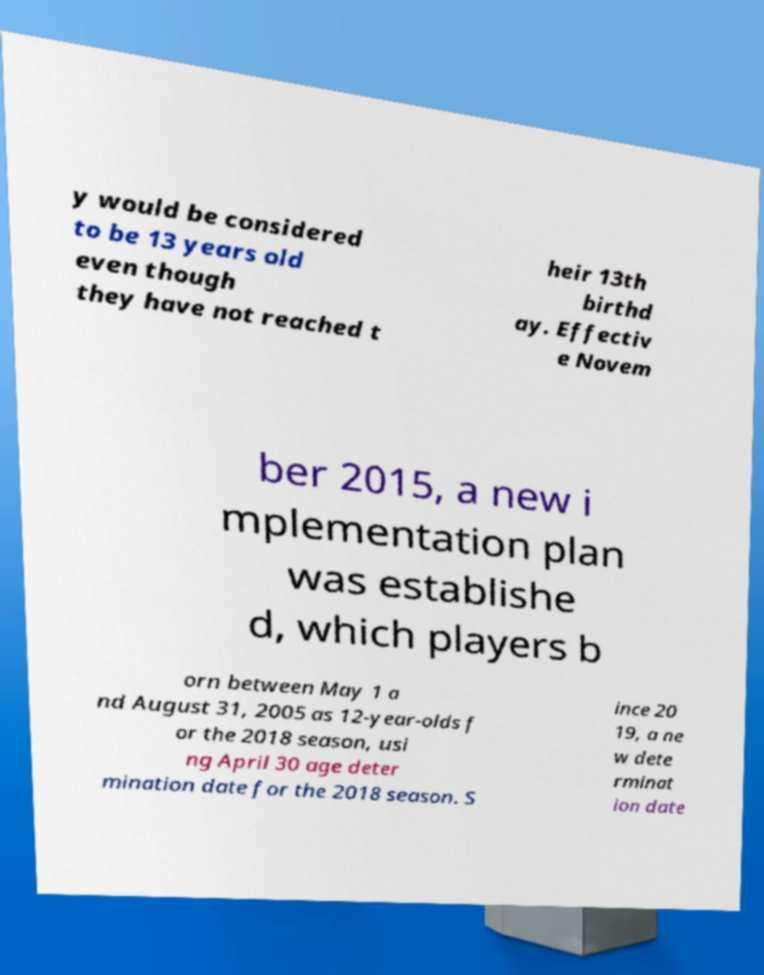Can you accurately transcribe the text from the provided image for me? y would be considered to be 13 years old even though they have not reached t heir 13th birthd ay. Effectiv e Novem ber 2015, a new i mplementation plan was establishe d, which players b orn between May 1 a nd August 31, 2005 as 12-year-olds f or the 2018 season, usi ng April 30 age deter mination date for the 2018 season. S ince 20 19, a ne w dete rminat ion date 